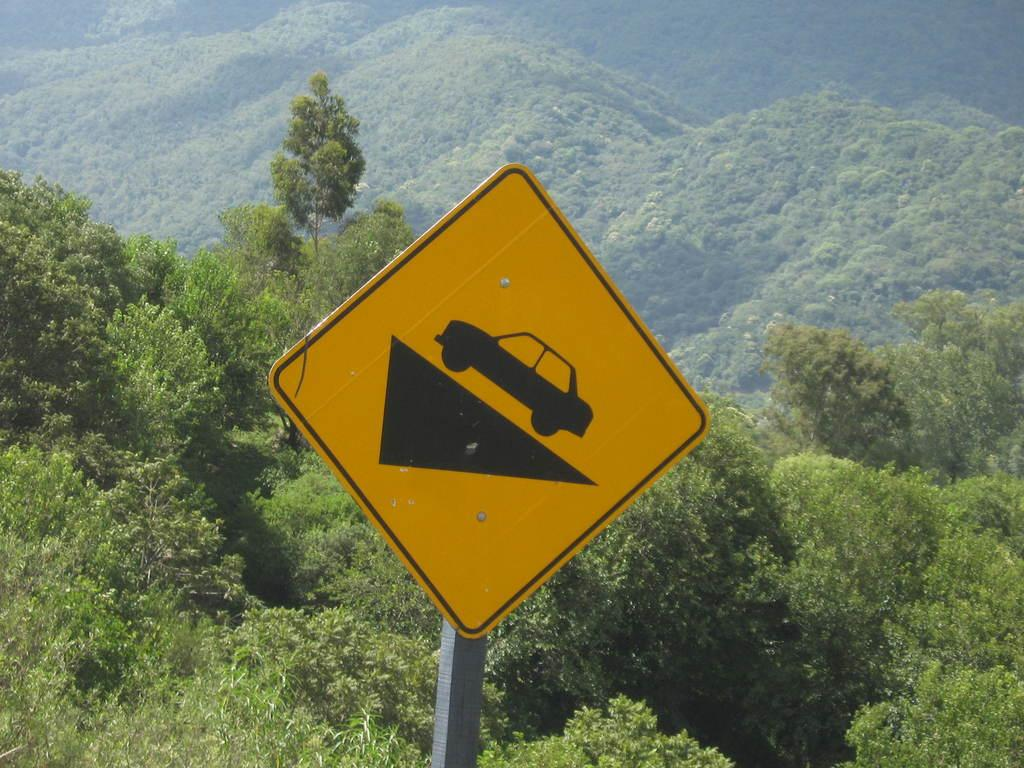What is the main object in the image? There is a sign board in the image. What can be seen in the background of the image? There is a mountain visible in the background of the image. What type of vegetation is present at the bottom of the image? There are many trees and plants at the bottom of the image. Can you see the partner of the person holding the boat on the coast in the image? There is no person holding a boat on the coast in the image, nor is there any reference to a partner. 